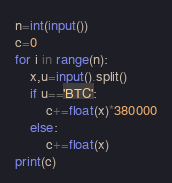<code> <loc_0><loc_0><loc_500><loc_500><_Python_>n=int(input())
c=0
for i in range(n):
    x,u=input().split()
    if u=='BTC':
        c+=float(x)*380000
    else:
        c+=float(x)
print(c)</code> 